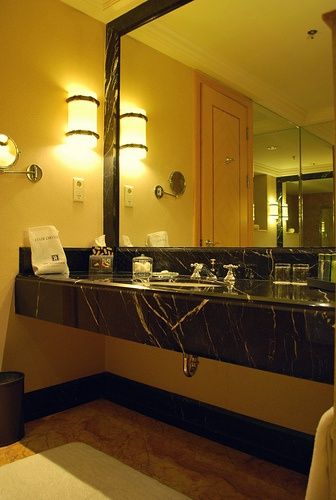Describe the objects in this image and their specific colors. I can see sink in olive and black tones, sink in olive, black, and tan tones, cup in olive and black tones, and cup in olive and black tones in this image. 